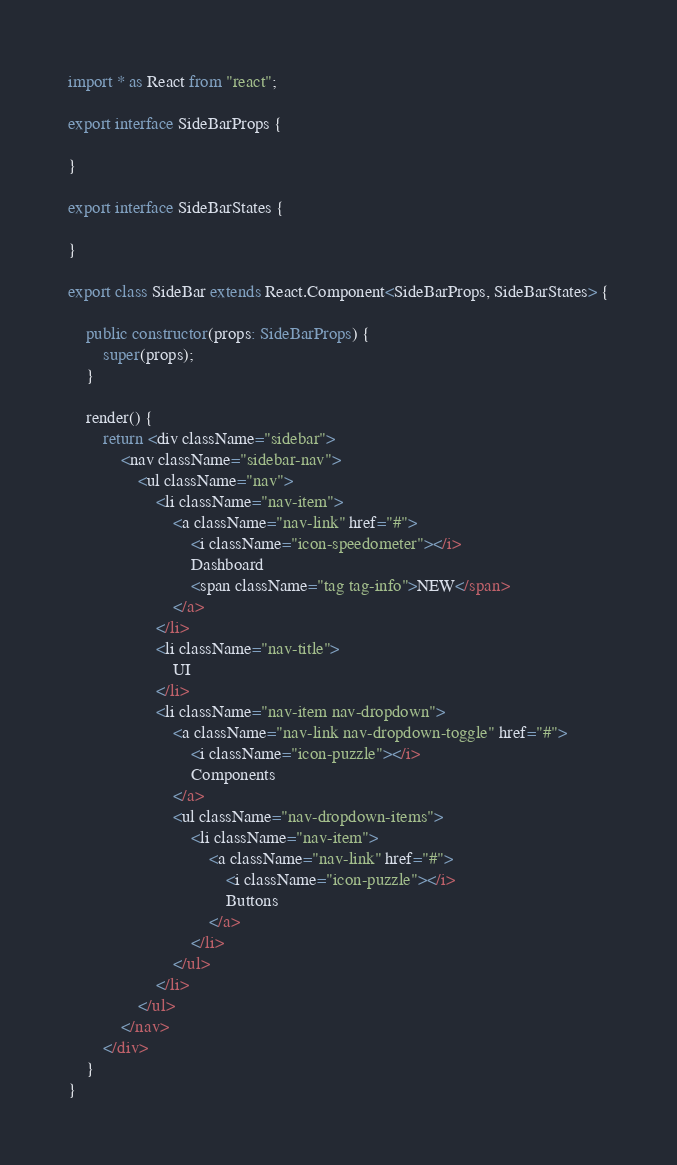<code> <loc_0><loc_0><loc_500><loc_500><_TypeScript_>import * as React from "react";

export interface SideBarProps {

}

export interface SideBarStates {

}

export class SideBar extends React.Component<SideBarProps, SideBarStates> {

    public constructor(props: SideBarProps) {
        super(props);
    }

    render() {
        return <div className="sidebar">
            <nav className="sidebar-nav">
                <ul className="nav">
                    <li className="nav-item">
                        <a className="nav-link" href="#">
                            <i className="icon-speedometer"></i>
                            Dashboard
                            <span className="tag tag-info">NEW</span>
                        </a>
                    </li>
                    <li className="nav-title">
                        UI
                    </li>
                    <li className="nav-item nav-dropdown">
                        <a className="nav-link nav-dropdown-toggle" href="#">
                            <i className="icon-puzzle"></i>
                            Components
                        </a>
                        <ul className="nav-dropdown-items">
                            <li className="nav-item">
                                <a className="nav-link" href="#">
                                    <i className="icon-puzzle"></i>
                                    Buttons
                                </a>
                            </li>
                        </ul>
                    </li>
                </ul>
            </nav>
        </div>
    }
}</code> 